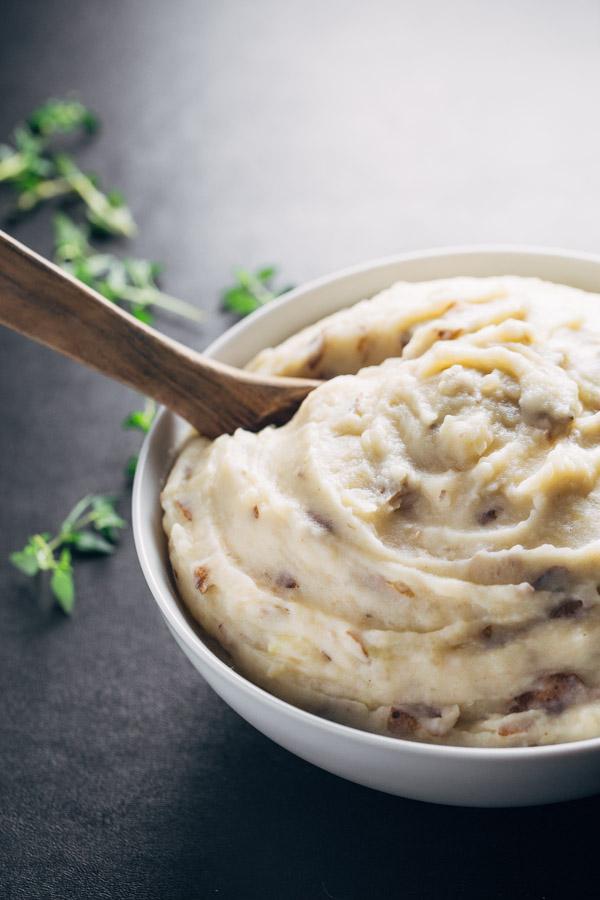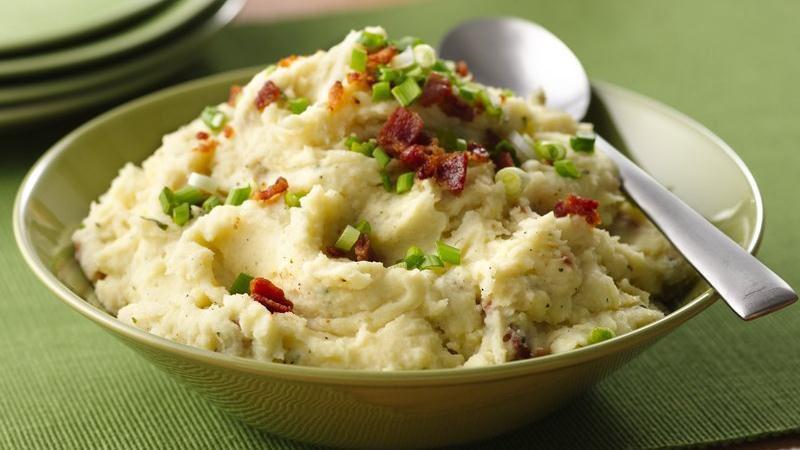The first image is the image on the left, the second image is the image on the right. Given the left and right images, does the statement "The left image shows a white bowl of food with a utensil handle sticking out, and the right image includes a spoon that is not sticking out of the food." hold true? Answer yes or no. Yes. The first image is the image on the left, the second image is the image on the right. Given the left and right images, does the statement "A silver spoon is set near the dish on the right." hold true? Answer yes or no. Yes. 